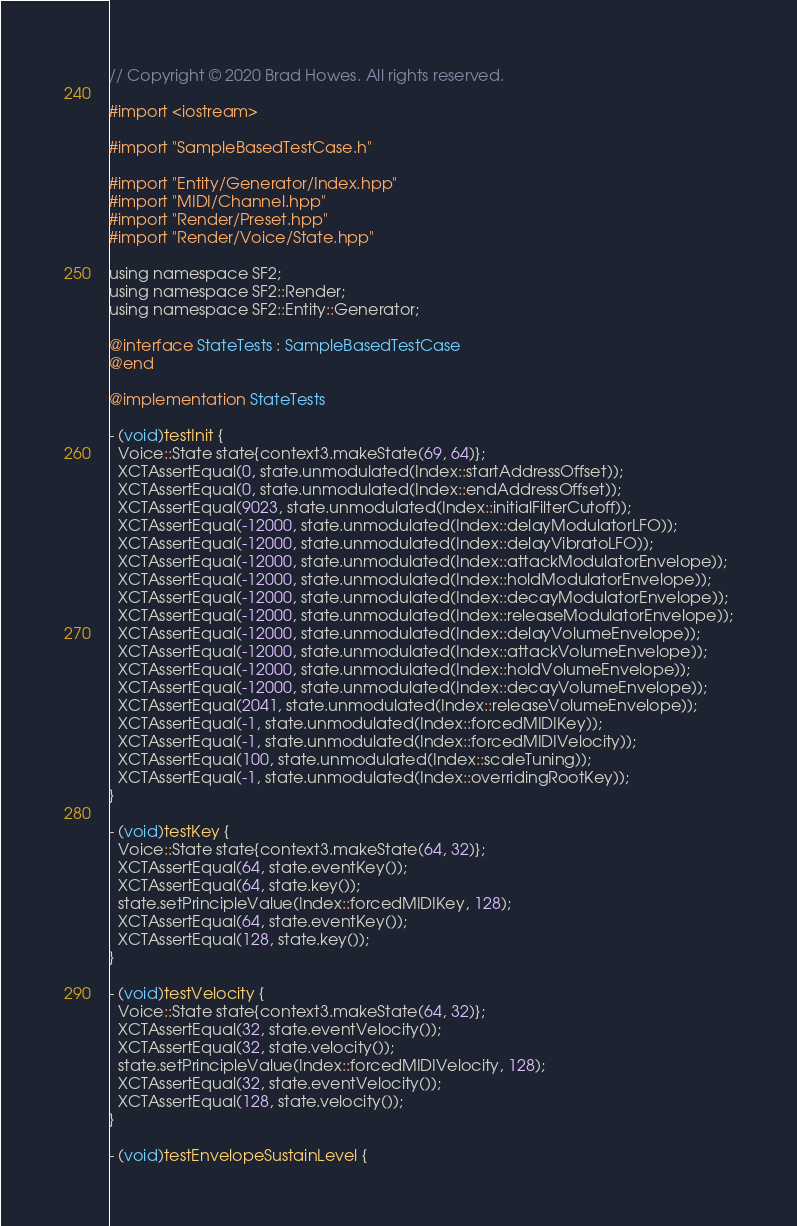<code> <loc_0><loc_0><loc_500><loc_500><_ObjectiveC_>// Copyright © 2020 Brad Howes. All rights reserved.

#import <iostream>

#import "SampleBasedTestCase.h"

#import "Entity/Generator/Index.hpp"
#import "MIDI/Channel.hpp"
#import "Render/Preset.hpp"
#import "Render/Voice/State.hpp"

using namespace SF2;
using namespace SF2::Render;
using namespace SF2::Entity::Generator;

@interface StateTests : SampleBasedTestCase
@end

@implementation StateTests

- (void)testInit {
  Voice::State state{context3.makeState(69, 64)};
  XCTAssertEqual(0, state.unmodulated(Index::startAddressOffset));
  XCTAssertEqual(0, state.unmodulated(Index::endAddressOffset));
  XCTAssertEqual(9023, state.unmodulated(Index::initialFilterCutoff));
  XCTAssertEqual(-12000, state.unmodulated(Index::delayModulatorLFO));
  XCTAssertEqual(-12000, state.unmodulated(Index::delayVibratoLFO));
  XCTAssertEqual(-12000, state.unmodulated(Index::attackModulatorEnvelope));
  XCTAssertEqual(-12000, state.unmodulated(Index::holdModulatorEnvelope));
  XCTAssertEqual(-12000, state.unmodulated(Index::decayModulatorEnvelope));
  XCTAssertEqual(-12000, state.unmodulated(Index::releaseModulatorEnvelope));
  XCTAssertEqual(-12000, state.unmodulated(Index::delayVolumeEnvelope));
  XCTAssertEqual(-12000, state.unmodulated(Index::attackVolumeEnvelope));
  XCTAssertEqual(-12000, state.unmodulated(Index::holdVolumeEnvelope));
  XCTAssertEqual(-12000, state.unmodulated(Index::decayVolumeEnvelope));
  XCTAssertEqual(2041, state.unmodulated(Index::releaseVolumeEnvelope));
  XCTAssertEqual(-1, state.unmodulated(Index::forcedMIDIKey));
  XCTAssertEqual(-1, state.unmodulated(Index::forcedMIDIVelocity));
  XCTAssertEqual(100, state.unmodulated(Index::scaleTuning));
  XCTAssertEqual(-1, state.unmodulated(Index::overridingRootKey));
}

- (void)testKey {
  Voice::State state{context3.makeState(64, 32)};
  XCTAssertEqual(64, state.eventKey());
  XCTAssertEqual(64, state.key());
  state.setPrincipleValue(Index::forcedMIDIKey, 128);
  XCTAssertEqual(64, state.eventKey());
  XCTAssertEqual(128, state.key());
}

- (void)testVelocity {
  Voice::State state{context3.makeState(64, 32)};
  XCTAssertEqual(32, state.eventVelocity());
  XCTAssertEqual(32, state.velocity());
  state.setPrincipleValue(Index::forcedMIDIVelocity, 128);
  XCTAssertEqual(32, state.eventVelocity());
  XCTAssertEqual(128, state.velocity());
}

- (void)testEnvelopeSustainLevel {</code> 